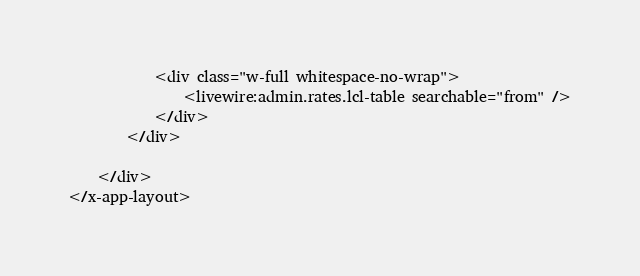<code> <loc_0><loc_0><loc_500><loc_500><_PHP_>            <div class="w-full whitespace-no-wrap">
                <livewire:admin.rates.lcl-table searchable="from" />
            </div>
        </div>

    </div>
</x-app-layout>
</code> 